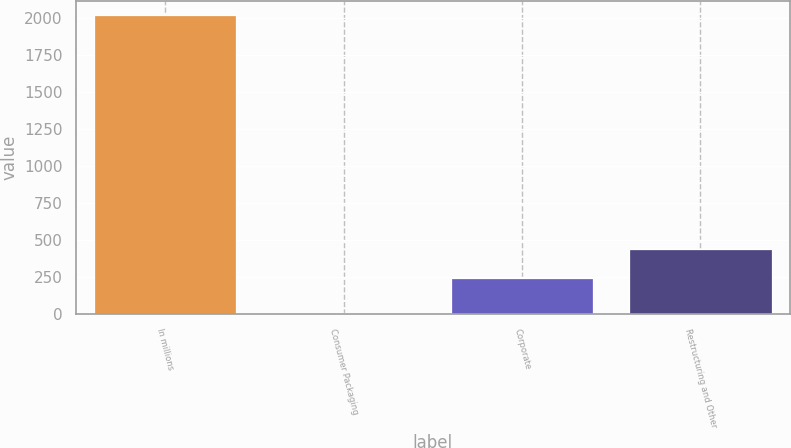Convert chart to OTSL. <chart><loc_0><loc_0><loc_500><loc_500><bar_chart><fcel>In millions<fcel>Consumer Packaging<fcel>Corporate<fcel>Restructuring and Other<nl><fcel>2015<fcel>10<fcel>242<fcel>442.5<nl></chart> 